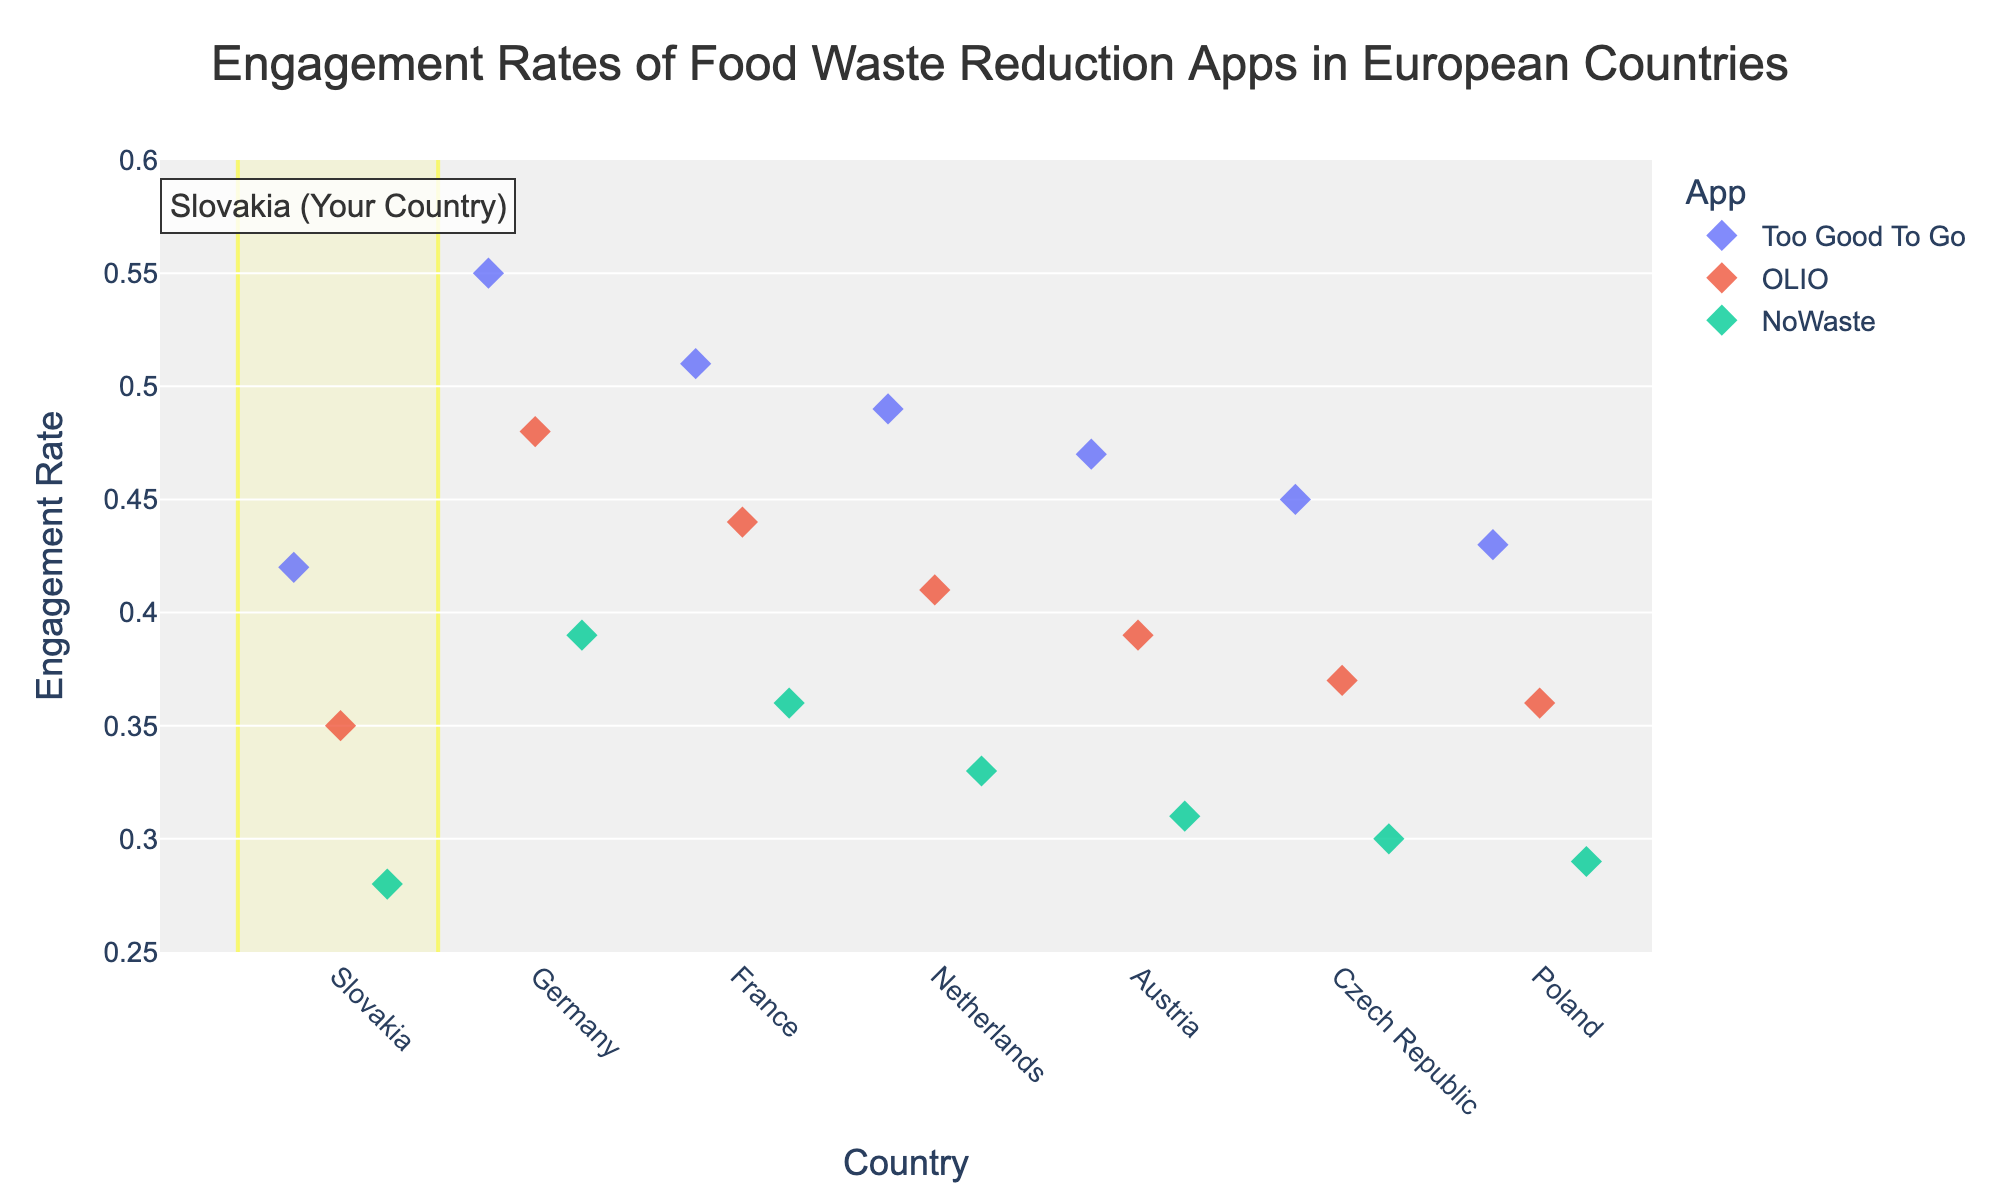What's the title of the figure? The figure's title is displayed at the top and reads "Engagement Rates of Food Waste Reduction Apps in European Countries".
Answer: Engagement Rates of Food Waste Reduction Apps in European Countries Which country is highlighted in the figure? The figure has a rectangular highlight and an annotation that specifies the highlighted country as Slovakia.
Answer: Slovakia Which app has the highest engagement rate in Slovakia according to the figure? In Slovakia, "Too Good To Go" has the highest engagement rate as indicated by the highest diamond marker in the Slovakia section.
Answer: Too Good To Go How does the engagement rate of "Too Good To Go" in Germany compare to that in Slovakia? The engagement rate of "Too Good To Go" in Germany is higher than in Slovakia, with Germany at 0.55 and Slovakia at 0.42.
Answer: Germany is higher What is the engagement rate of OLIO in France and how does it compare to that in Austria? The engagement rate of OLIO in France is 0.44, while in Austria it is 0.39. The engagement rate in France is higher.
Answer: France is higher Calculate the average engagement rate for the app "NoWaste" across all listed countries. Adding the engagement rates of NoWaste across all listed countries: 0.28 (Slovakia) + 0.39 (Germany) + 0.36 (France) + 0.33 (Netherlands) + 0.31 (Austria) + 0.30 (Czech Republic) + 0.29 (Poland) = 2.26. There are 7 countries, so the average is 2.26 / 7 = 0.323.
Answer: 0.323 In which country does the app OLIO have the lowest engagement rate? The figure shows that the lowest engagement rate for OLIO is in Czech Republic, at 0.37.
Answer: Czech Republic Between the Netherlands and Poland, which country has a higher engagement rate for NoWaste? The engagement rate for NoWaste is 0.33 in the Netherlands and 0.29 in Poland. Thus, the Netherlands has a higher engagement rate.
Answer: Netherlands What is the range of engagement rates for "Too Good To Go" across all countries? The engagement rates for "Too Good To Go" range from the lowest value of 0.42 in Slovakia to the highest value of 0.55 in Germany. Therefore, the range is 0.55 - 0.42 = 0.13.
Answer: 0.13 In how many countries does "Too Good To Go" have an engagement rate above 0.45? According to the figure, "Too Good To Go" has an engagement rate above 0.45 in Germany (0.55), France (0.51), Netherlands (0.49), Austria (0.47), and Czech Republic (0.45). That makes a total of 5 countries.
Answer: 5 